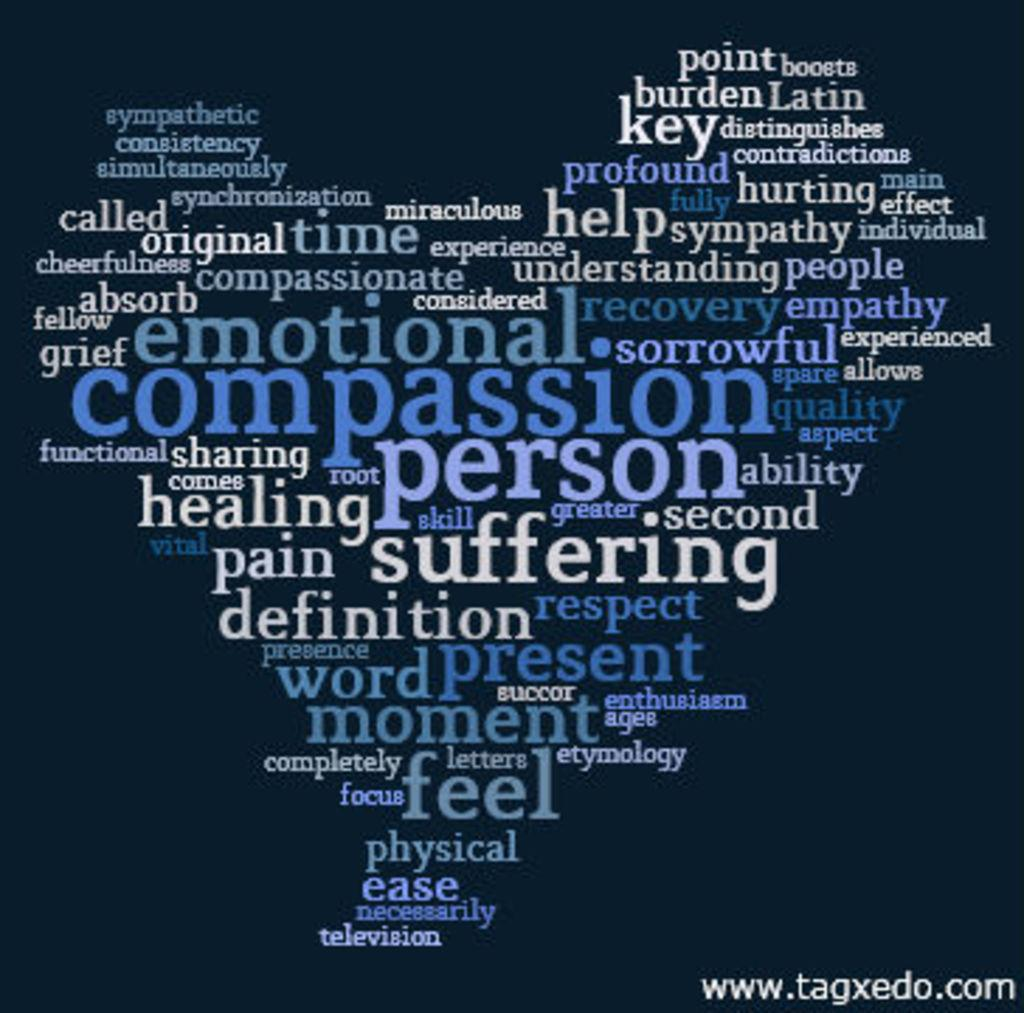<image>
Render a clear and concise summary of the photo. A word cloud of various emotions and and objects with compassion in the center. 